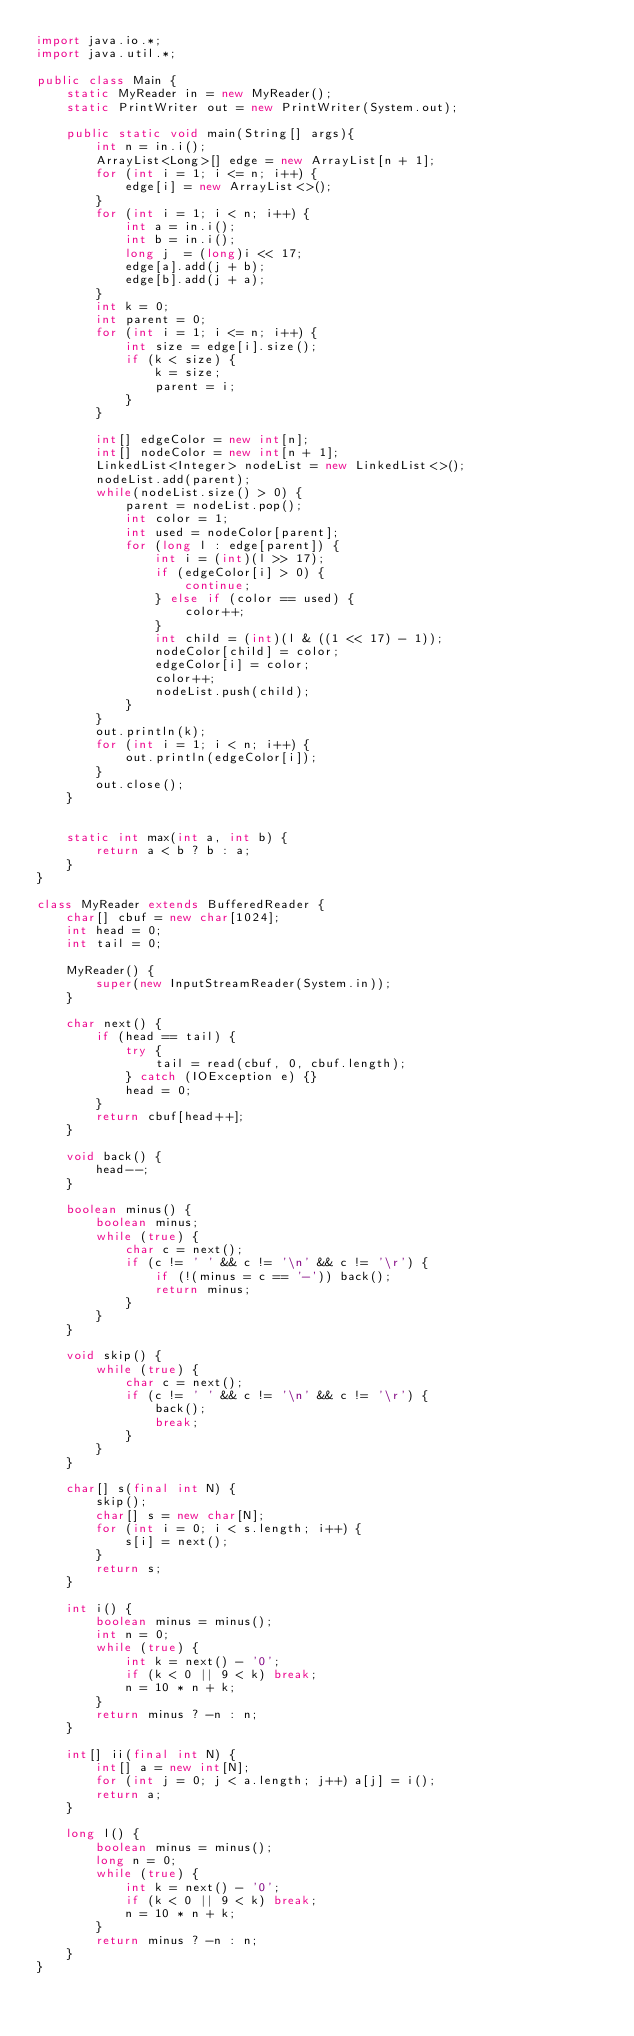<code> <loc_0><loc_0><loc_500><loc_500><_Java_>import java.io.*;
import java.util.*;

public class Main {
    static MyReader in = new MyReader();
    static PrintWriter out = new PrintWriter(System.out);

    public static void main(String[] args){
        int n = in.i();
        ArrayList<Long>[] edge = new ArrayList[n + 1];
        for (int i = 1; i <= n; i++) {
            edge[i] = new ArrayList<>();
        }
        for (int i = 1; i < n; i++) {
            int a = in.i();
            int b = in.i();
            long j  = (long)i << 17;
            edge[a].add(j + b);
            edge[b].add(j + a);
        }
        int k = 0;
        int parent = 0;
        for (int i = 1; i <= n; i++) {
            int size = edge[i].size();
            if (k < size) {
                k = size;
                parent = i;
            }
        }

        int[] edgeColor = new int[n];
        int[] nodeColor = new int[n + 1];
        LinkedList<Integer> nodeList = new LinkedList<>();
        nodeList.add(parent);
        while(nodeList.size() > 0) {
            parent = nodeList.pop();
            int color = 1;
            int used = nodeColor[parent];
            for (long l : edge[parent]) {
                int i = (int)(l >> 17);
                if (edgeColor[i] > 0) {
                    continue;
                } else if (color == used) {
                    color++;
                }
                int child = (int)(l & ((1 << 17) - 1));
                nodeColor[child] = color;
                edgeColor[i] = color;
                color++;
                nodeList.push(child);
            }
        }
        out.println(k);
        for (int i = 1; i < n; i++) {
            out.println(edgeColor[i]);
        }
        out.close();
    }


    static int max(int a, int b) {
        return a < b ? b : a;
    }
}

class MyReader extends BufferedReader {
    char[] cbuf = new char[1024];
    int head = 0;
    int tail = 0;

    MyReader() {
        super(new InputStreamReader(System.in));
    }

    char next() {
        if (head == tail) {
            try {
                tail = read(cbuf, 0, cbuf.length);
            } catch (IOException e) {}
            head = 0;
        }
        return cbuf[head++];
    }

    void back() {
        head--;
    }

    boolean minus() {
        boolean minus;
        while (true) {
            char c = next();
            if (c != ' ' && c != '\n' && c != '\r') {
                if (!(minus = c == '-')) back();
                return minus;
            }
        }
    }

    void skip() {
        while (true) {
            char c = next();
            if (c != ' ' && c != '\n' && c != '\r') {
                back();
                break;
            }
        }
    }

    char[] s(final int N) {
        skip();
        char[] s = new char[N];
        for (int i = 0; i < s.length; i++) {
            s[i] = next();
        }
        return s;
    }

    int i() {
        boolean minus = minus();
        int n = 0;
        while (true) {
            int k = next() - '0';
            if (k < 0 || 9 < k) break;
            n = 10 * n + k;
        }
        return minus ? -n : n;
    }

    int[] ii(final int N) {
        int[] a = new int[N];
        for (int j = 0; j < a.length; j++) a[j] = i();
        return a;
    }

    long l() {
        boolean minus = minus();
        long n = 0;
        while (true) {
            int k = next() - '0';
            if (k < 0 || 9 < k) break;
            n = 10 * n + k;
        }
        return minus ? -n : n;
    }
}
</code> 